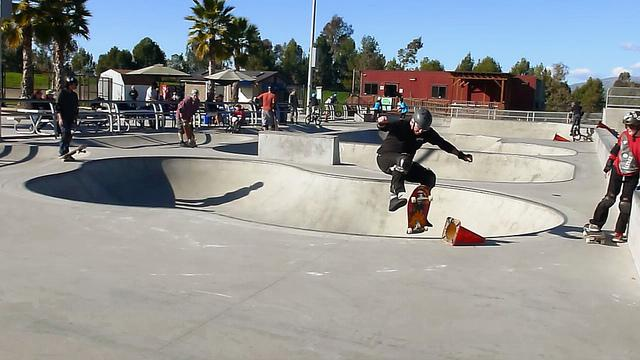Why have the skaters covered their heads?

Choices:
A) warmth
B) uniform
C) fashion
D) protection protection 